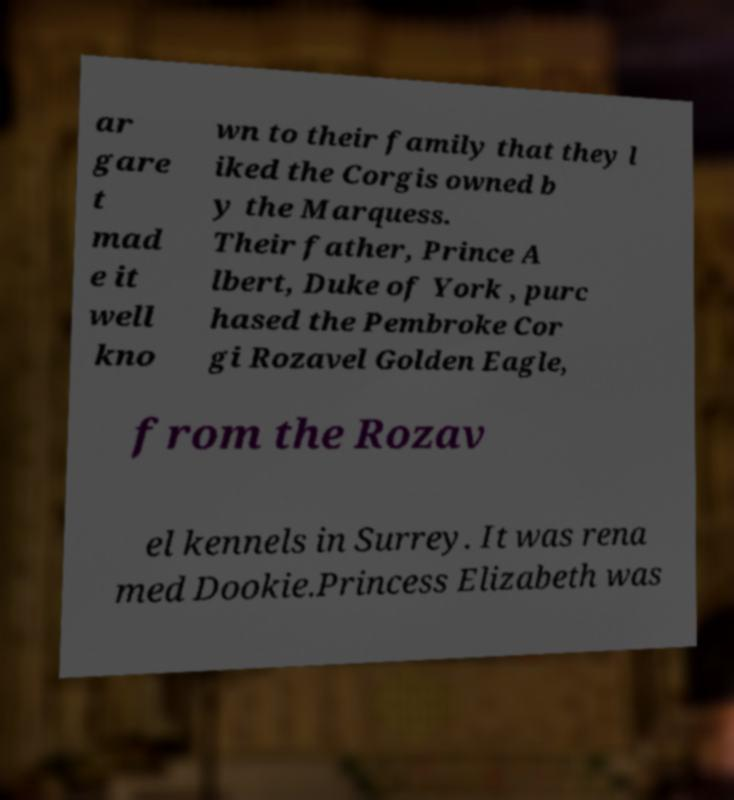There's text embedded in this image that I need extracted. Can you transcribe it verbatim? ar gare t mad e it well kno wn to their family that they l iked the Corgis owned b y the Marquess. Their father, Prince A lbert, Duke of York , purc hased the Pembroke Cor gi Rozavel Golden Eagle, from the Rozav el kennels in Surrey. It was rena med Dookie.Princess Elizabeth was 